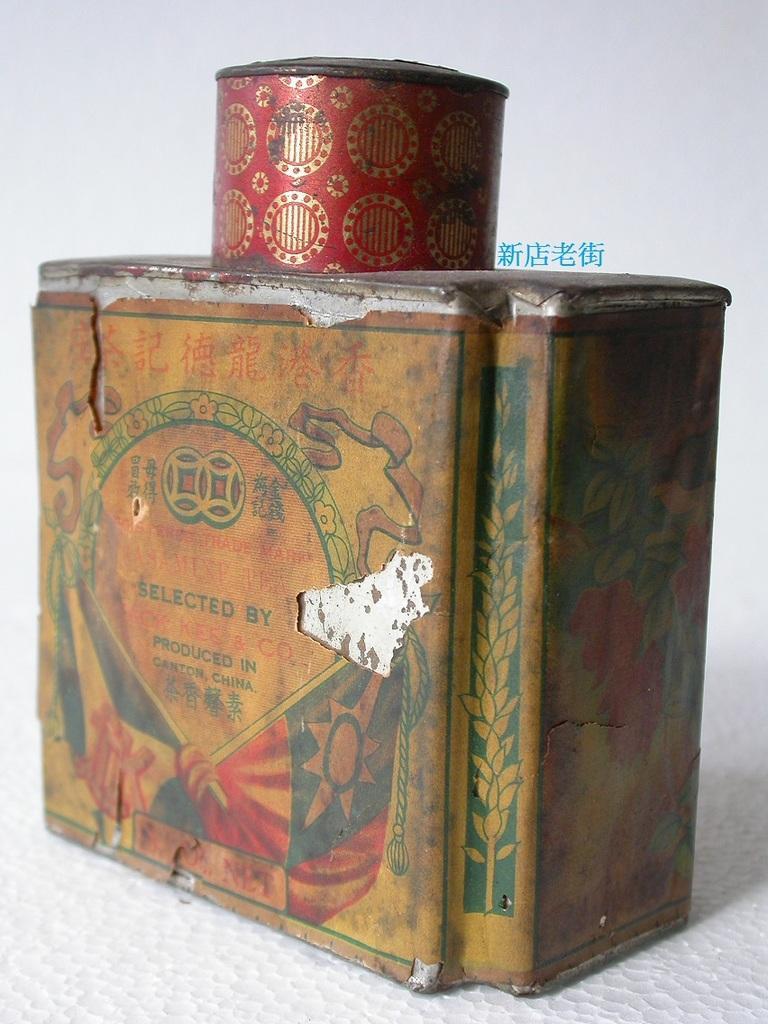Describe this image in one or two sentences. In this image we can see an object on a white surface. On the object we can see a label. 